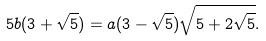Convert formula to latex. <formula><loc_0><loc_0><loc_500><loc_500>5 b ( 3 + \sqrt { 5 } ) = a ( 3 - \sqrt { 5 } ) \sqrt { 5 + 2 \sqrt { 5 } } .</formula> 